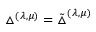Convert formula to latex. <formula><loc_0><loc_0><loc_500><loc_500>\bigtriangleup ^ { ( \lambda , \mu ) } = \tilde { \bigtriangleup } ^ { ( \lambda , \mu ) }</formula> 